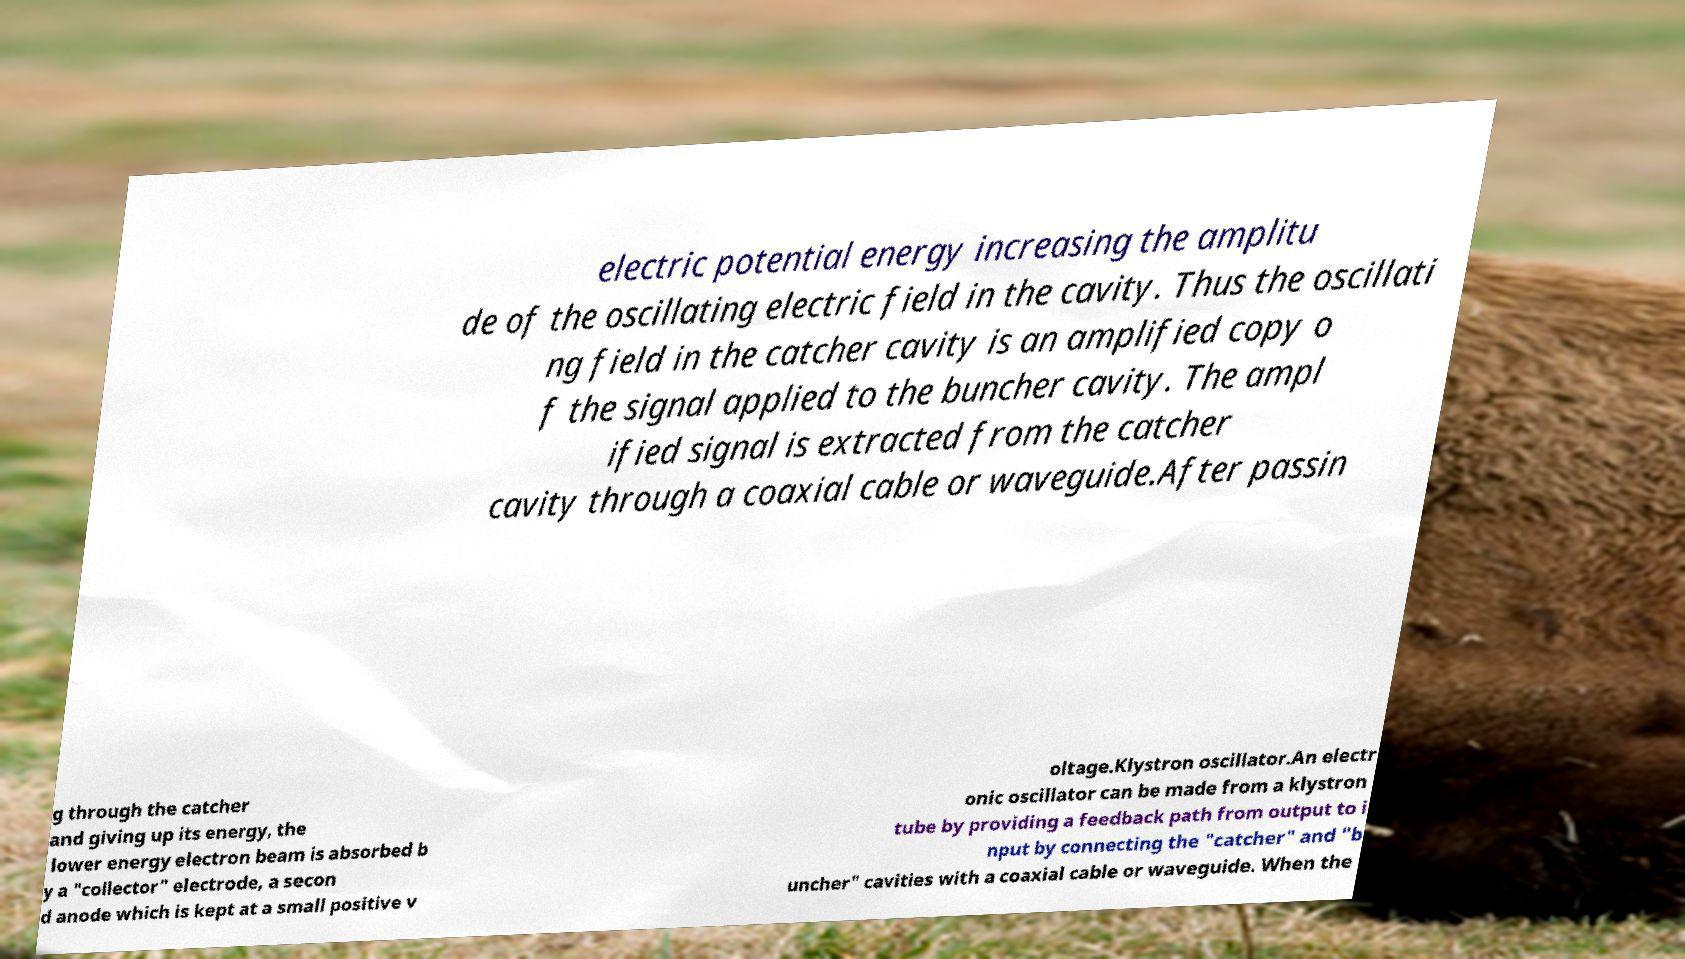Can you read and provide the text displayed in the image?This photo seems to have some interesting text. Can you extract and type it out for me? electric potential energy increasing the amplitu de of the oscillating electric field in the cavity. Thus the oscillati ng field in the catcher cavity is an amplified copy o f the signal applied to the buncher cavity. The ampl ified signal is extracted from the catcher cavity through a coaxial cable or waveguide.After passin g through the catcher and giving up its energy, the lower energy electron beam is absorbed b y a "collector" electrode, a secon d anode which is kept at a small positive v oltage.Klystron oscillator.An electr onic oscillator can be made from a klystron tube by providing a feedback path from output to i nput by connecting the "catcher" and "b uncher" cavities with a coaxial cable or waveguide. When the 